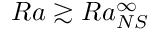Convert formula to latex. <formula><loc_0><loc_0><loc_500><loc_500>R a \gtrsim R a _ { N S } ^ { \infty }</formula> 